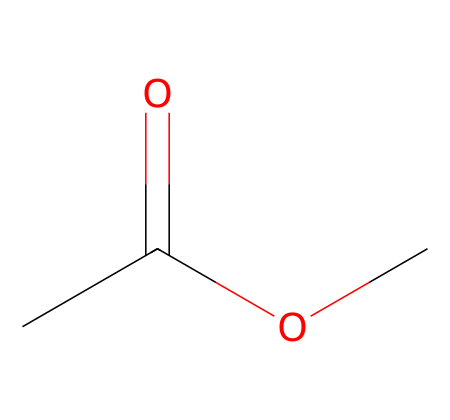What is the molecular formula of this compound? The compound is represented by the SMILES notation CC(=O)OC, which provides information about the number and types of atoms present. Breaking this down: "CC" indicates two carbon atoms, "O" represents oxygen atoms (there are two), and "H" atoms implicitly connect to carbon. Thus, the molecular formula combines these to give C3H6O2.
Answer: C3H6O2 How many total atoms are in the molecule? In the chemical represented (CC(=O)OC), we have 3 carbon atoms, 6 hydrogen atoms, and 2 oxygen atoms. Adding these gives 3+6+2 = 11 total atoms in the molecule.
Answer: 11 What type of functional group is present in the molecule? Analyzing the structure reveals a carbonyl group (C=O) from the "C(=O)" portion, and an ether group (C-O-C) from "OC". The carbonyl group is characteristic of esters, which is the primary functional group in the molecule.
Answer: ester How many carbon atoms are involved in the molecule? From the SMILES CC(=O)OC, we can count the "C" characters: there are three distinct carbon atoms present in the structure. Therefore, the answer is three carbon atoms are involved.
Answer: 3 Does the structure indicate the presence of any double bonds? The structure CC(=O)OC reveals a double bond between the carbon (C) and oxygen (O) within the carbonyl group (C=O). This confirms that at least one double bond is present in the molecule.
Answer: yes Is this compound likely to be soluble in water? Given the presence of polar functional groups (carbonyl and ether), this compound is expected to interact favorably with water molecules. Therefore, its solubility is likely due to these polar characteristics that allow it to dissolve in water.
Answer: yes 